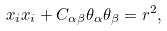Convert formula to latex. <formula><loc_0><loc_0><loc_500><loc_500>x _ { i } x _ { i } + C _ { \alpha \beta } \theta _ { \alpha } \theta _ { \beta } = r ^ { 2 } ,</formula> 